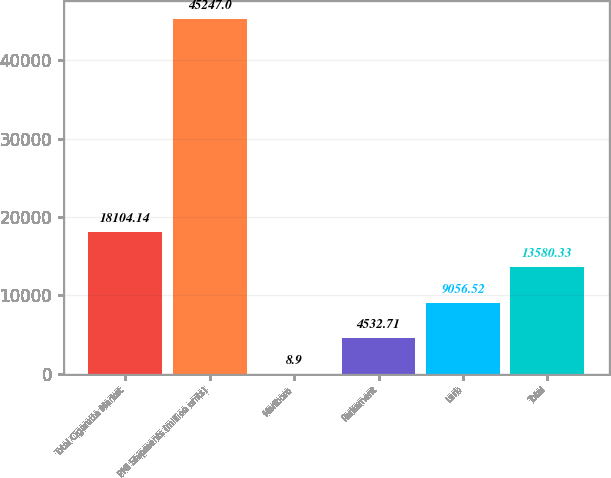<chart> <loc_0><loc_0><loc_500><loc_500><bar_chart><fcel>Total Cigarette Market<fcel>PMI Shipments (million units)<fcel>Marlboro<fcel>Parliament<fcel>Lark<fcel>Total<nl><fcel>18104.1<fcel>45247<fcel>8.9<fcel>4532.71<fcel>9056.52<fcel>13580.3<nl></chart> 